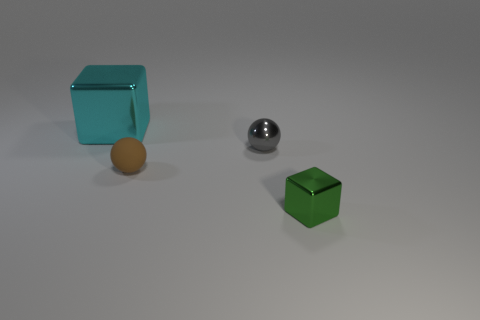Do the small thing that is behind the small brown matte object and the small object in front of the small brown rubber ball have the same shape?
Offer a very short reply. No. There is another object that is the same shape as the tiny gray thing; what is its material?
Ensure brevity in your answer.  Rubber. What number of cubes are matte objects or tiny green objects?
Offer a terse response. 1. What number of spheres are the same material as the small block?
Make the answer very short. 1. Is the material of the block behind the green cube the same as the block to the right of the large cyan metal block?
Give a very brief answer. Yes. There is a ball that is in front of the small ball right of the small rubber object; how many big shiny objects are left of it?
Make the answer very short. 1. Is there anything else of the same color as the tiny metallic cube?
Provide a short and direct response. No. There is a metallic cube behind the metal cube on the right side of the large block; what color is it?
Offer a very short reply. Cyan. Are any tiny red matte cubes visible?
Offer a terse response. No. There is a thing that is both in front of the big object and left of the gray shiny sphere; what color is it?
Provide a succinct answer. Brown. 